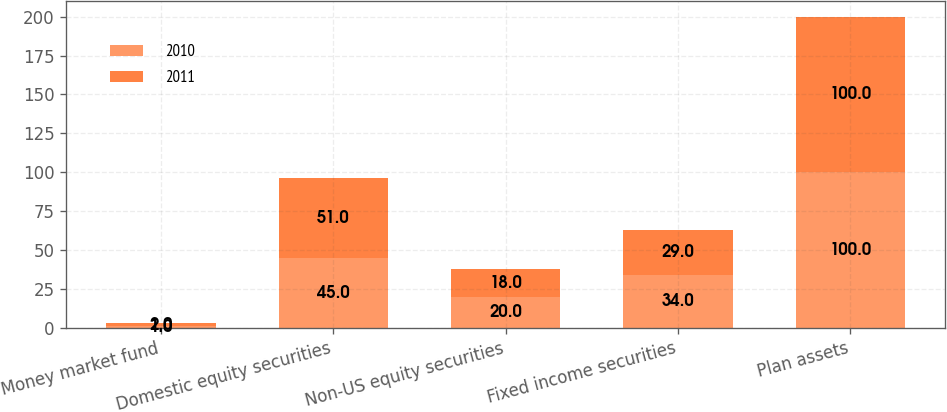Convert chart to OTSL. <chart><loc_0><loc_0><loc_500><loc_500><stacked_bar_chart><ecel><fcel>Money market fund<fcel>Domestic equity securities<fcel>Non-US equity securities<fcel>Fixed income securities<fcel>Plan assets<nl><fcel>2010<fcel>1<fcel>45<fcel>20<fcel>34<fcel>100<nl><fcel>2011<fcel>2<fcel>51<fcel>18<fcel>29<fcel>100<nl></chart> 